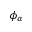Convert formula to latex. <formula><loc_0><loc_0><loc_500><loc_500>\phi _ { \alpha }</formula> 